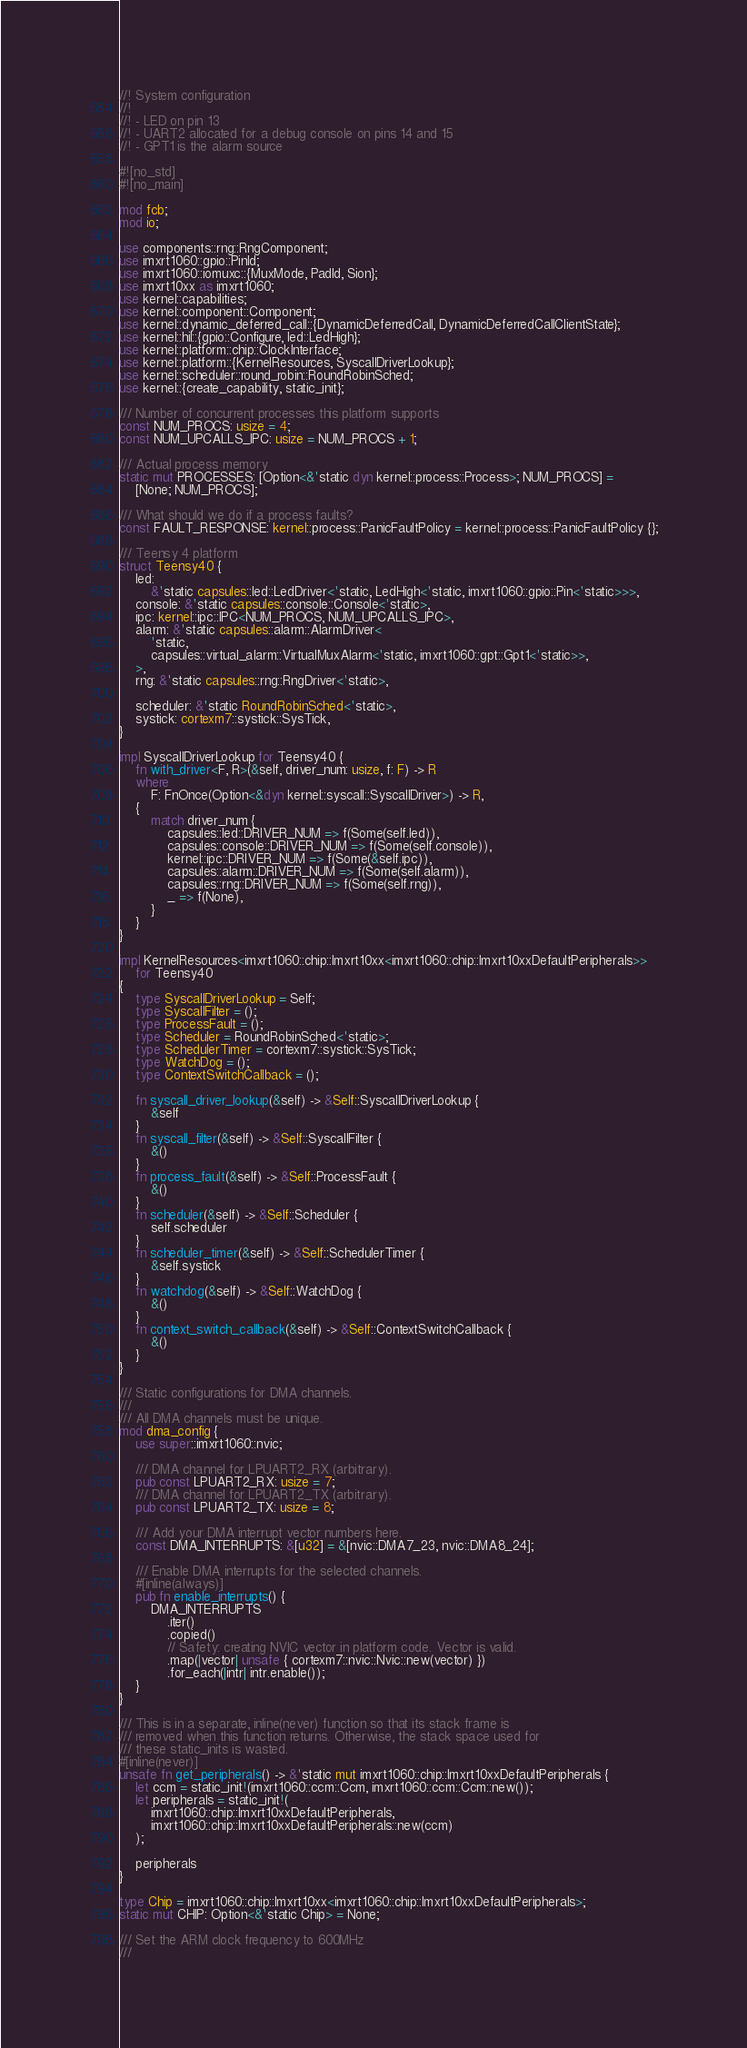Convert code to text. <code><loc_0><loc_0><loc_500><loc_500><_Rust_>//! System configuration
//!
//! - LED on pin 13
//! - UART2 allocated for a debug console on pins 14 and 15
//! - GPT1 is the alarm source

#![no_std]
#![no_main]

mod fcb;
mod io;

use components::rng::RngComponent;
use imxrt1060::gpio::PinId;
use imxrt1060::iomuxc::{MuxMode, PadId, Sion};
use imxrt10xx as imxrt1060;
use kernel::capabilities;
use kernel::component::Component;
use kernel::dynamic_deferred_call::{DynamicDeferredCall, DynamicDeferredCallClientState};
use kernel::hil::{gpio::Configure, led::LedHigh};
use kernel::platform::chip::ClockInterface;
use kernel::platform::{KernelResources, SyscallDriverLookup};
use kernel::scheduler::round_robin::RoundRobinSched;
use kernel::{create_capability, static_init};

/// Number of concurrent processes this platform supports
const NUM_PROCS: usize = 4;
const NUM_UPCALLS_IPC: usize = NUM_PROCS + 1;

/// Actual process memory
static mut PROCESSES: [Option<&'static dyn kernel::process::Process>; NUM_PROCS] =
    [None; NUM_PROCS];

/// What should we do if a process faults?
const FAULT_RESPONSE: kernel::process::PanicFaultPolicy = kernel::process::PanicFaultPolicy {};

/// Teensy 4 platform
struct Teensy40 {
    led:
        &'static capsules::led::LedDriver<'static, LedHigh<'static, imxrt1060::gpio::Pin<'static>>>,
    console: &'static capsules::console::Console<'static>,
    ipc: kernel::ipc::IPC<NUM_PROCS, NUM_UPCALLS_IPC>,
    alarm: &'static capsules::alarm::AlarmDriver<
        'static,
        capsules::virtual_alarm::VirtualMuxAlarm<'static, imxrt1060::gpt::Gpt1<'static>>,
    >,
    rng: &'static capsules::rng::RngDriver<'static>,

    scheduler: &'static RoundRobinSched<'static>,
    systick: cortexm7::systick::SysTick,
}

impl SyscallDriverLookup for Teensy40 {
    fn with_driver<F, R>(&self, driver_num: usize, f: F) -> R
    where
        F: FnOnce(Option<&dyn kernel::syscall::SyscallDriver>) -> R,
    {
        match driver_num {
            capsules::led::DRIVER_NUM => f(Some(self.led)),
            capsules::console::DRIVER_NUM => f(Some(self.console)),
            kernel::ipc::DRIVER_NUM => f(Some(&self.ipc)),
            capsules::alarm::DRIVER_NUM => f(Some(self.alarm)),
            capsules::rng::DRIVER_NUM => f(Some(self.rng)),
            _ => f(None),
        }
    }
}

impl KernelResources<imxrt1060::chip::Imxrt10xx<imxrt1060::chip::Imxrt10xxDefaultPeripherals>>
    for Teensy40
{
    type SyscallDriverLookup = Self;
    type SyscallFilter = ();
    type ProcessFault = ();
    type Scheduler = RoundRobinSched<'static>;
    type SchedulerTimer = cortexm7::systick::SysTick;
    type WatchDog = ();
    type ContextSwitchCallback = ();

    fn syscall_driver_lookup(&self) -> &Self::SyscallDriverLookup {
        &self
    }
    fn syscall_filter(&self) -> &Self::SyscallFilter {
        &()
    }
    fn process_fault(&self) -> &Self::ProcessFault {
        &()
    }
    fn scheduler(&self) -> &Self::Scheduler {
        self.scheduler
    }
    fn scheduler_timer(&self) -> &Self::SchedulerTimer {
        &self.systick
    }
    fn watchdog(&self) -> &Self::WatchDog {
        &()
    }
    fn context_switch_callback(&self) -> &Self::ContextSwitchCallback {
        &()
    }
}

/// Static configurations for DMA channels.
///
/// All DMA channels must be unique.
mod dma_config {
    use super::imxrt1060::nvic;

    /// DMA channel for LPUART2_RX (arbitrary).
    pub const LPUART2_RX: usize = 7;
    /// DMA channel for LPUART2_TX (arbitrary).
    pub const LPUART2_TX: usize = 8;

    /// Add your DMA interrupt vector numbers here.
    const DMA_INTERRUPTS: &[u32] = &[nvic::DMA7_23, nvic::DMA8_24];

    /// Enable DMA interrupts for the selected channels.
    #[inline(always)]
    pub fn enable_interrupts() {
        DMA_INTERRUPTS
            .iter()
            .copied()
            // Safety: creating NVIC vector in platform code. Vector is valid.
            .map(|vector| unsafe { cortexm7::nvic::Nvic::new(vector) })
            .for_each(|intr| intr.enable());
    }
}

/// This is in a separate, inline(never) function so that its stack frame is
/// removed when this function returns. Otherwise, the stack space used for
/// these static_inits is wasted.
#[inline(never)]
unsafe fn get_peripherals() -> &'static mut imxrt1060::chip::Imxrt10xxDefaultPeripherals {
    let ccm = static_init!(imxrt1060::ccm::Ccm, imxrt1060::ccm::Ccm::new());
    let peripherals = static_init!(
        imxrt1060::chip::Imxrt10xxDefaultPeripherals,
        imxrt1060::chip::Imxrt10xxDefaultPeripherals::new(ccm)
    );

    peripherals
}

type Chip = imxrt1060::chip::Imxrt10xx<imxrt1060::chip::Imxrt10xxDefaultPeripherals>;
static mut CHIP: Option<&'static Chip> = None;

/// Set the ARM clock frequency to 600MHz
///</code> 